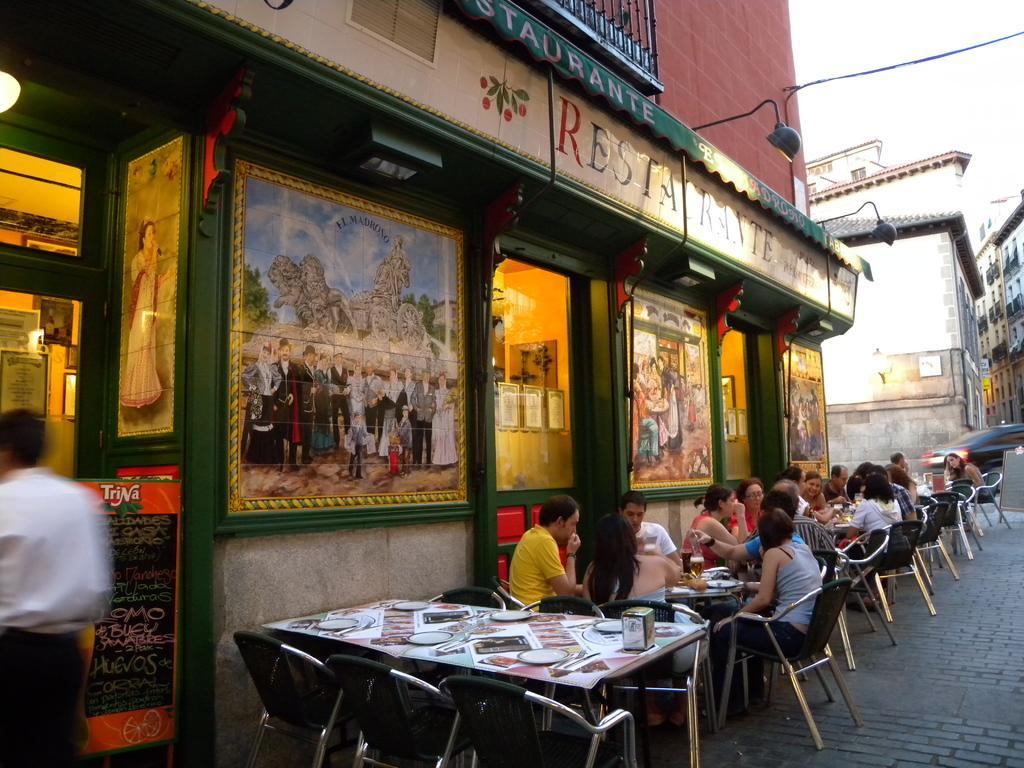Describe this image in one or two sentences. Here we can see some persons are sitting on the chairs. These are the tables. On the table there are plates, bottle, and a box. This is road. Here we can see some buildings. There are frames. Here we can see a man who is standing on the road. There is a light and this is board. Here we can see sky. 